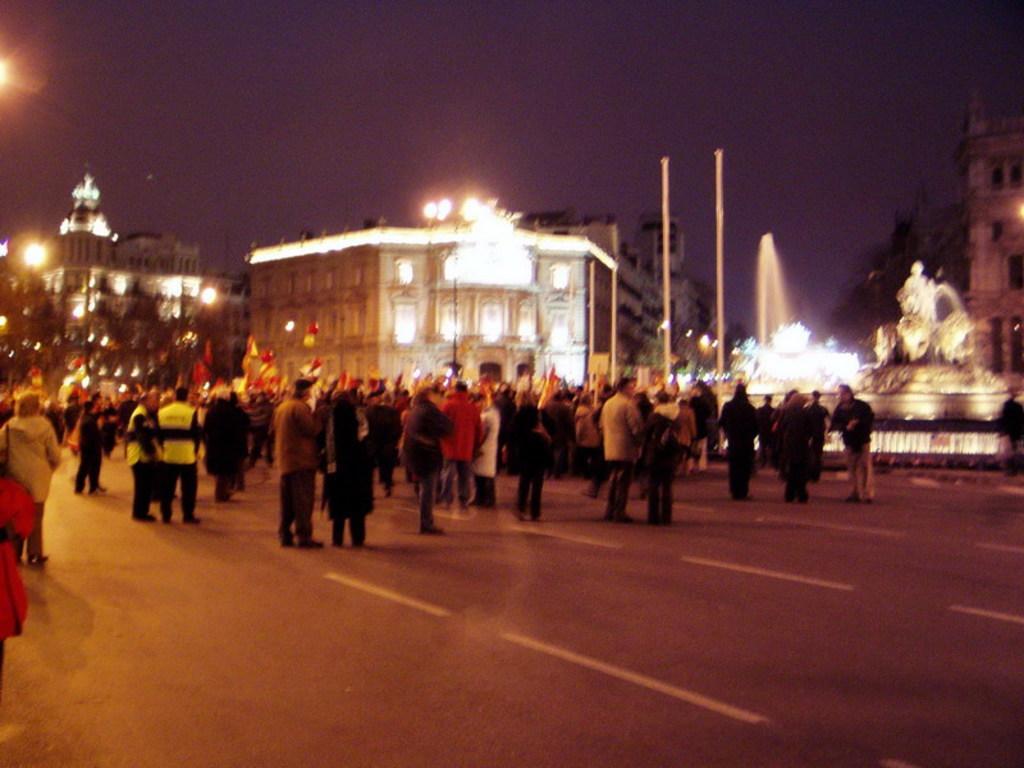Please provide a concise description of this image. In this image we can see there is a group of people standing on the road. And there are objects. There are buildings, trees, fountain, pole and there is a statue. And at the top there is a sky. 